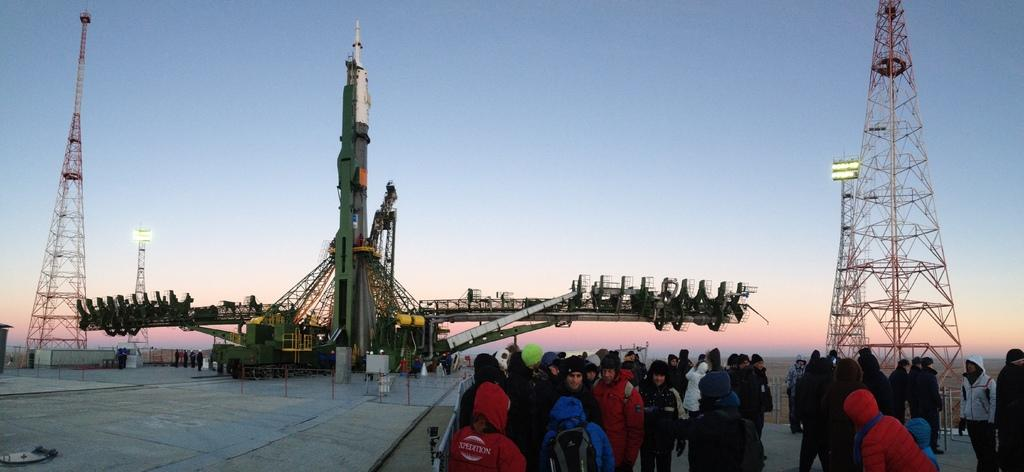How many people are present in the image? There are many people in the image. What are the people wearing? The people are wearing clothes. What structures can be seen in the image? There are towers in the image. What is the large object in the image? There is a rocket in the image. What is the platform used for in the image? The platform is present in the image. What is visible in the sky in the image? The sky is visible in the image. What type of throat medicine is being administered to the expert in the image? There is no expert or throat medicine present in the image. What is the rod used for in the image? There is no rod present in the image. 